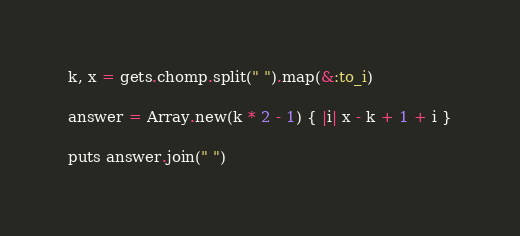<code> <loc_0><loc_0><loc_500><loc_500><_Ruby_>k, x = gets.chomp.split(" ").map(&:to_i)

answer = Array.new(k * 2 - 1) { |i| x - k + 1 + i }

puts answer.join(" ")
</code> 